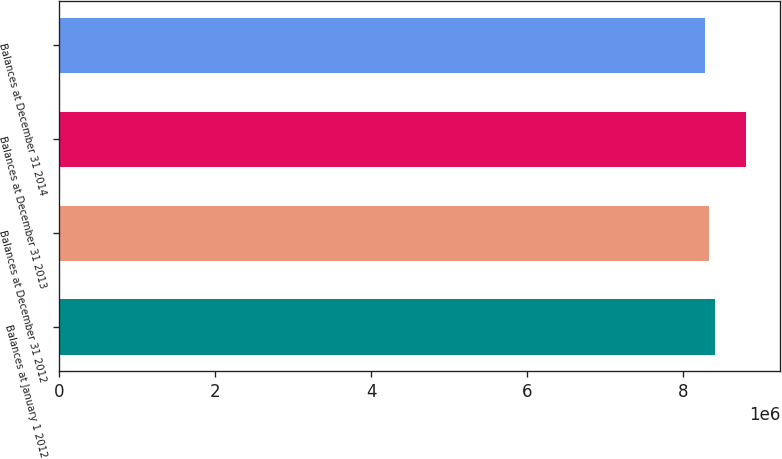<chart> <loc_0><loc_0><loc_500><loc_500><bar_chart><fcel>Balances at January 1 2012<fcel>Balances at December 31 2012<fcel>Balances at December 31 2013<fcel>Balances at December 31 2014<nl><fcel>8.40782e+06<fcel>8.33675e+06<fcel>8.80826e+06<fcel>8.28436e+06<nl></chart> 